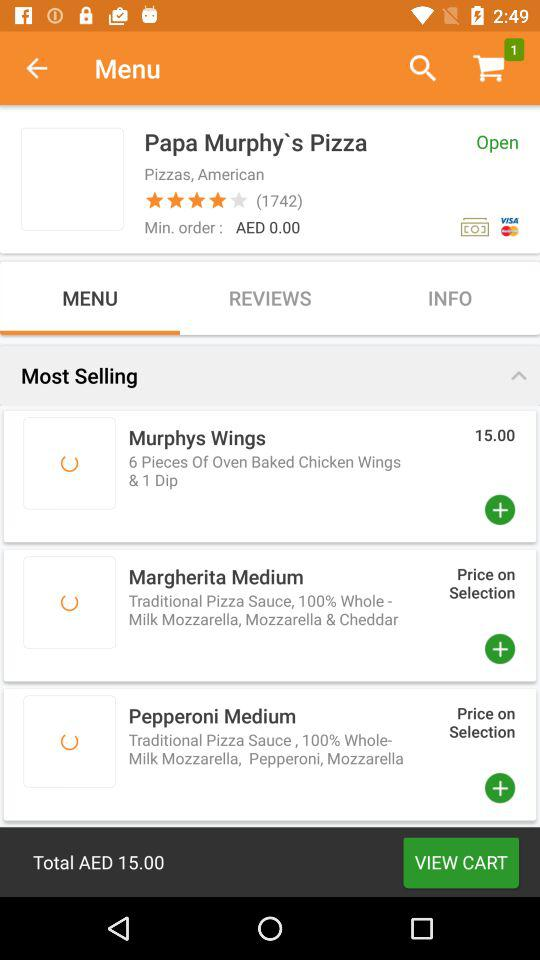How many items are there in the shopping cart? There is 1 item in the shopping cart. 